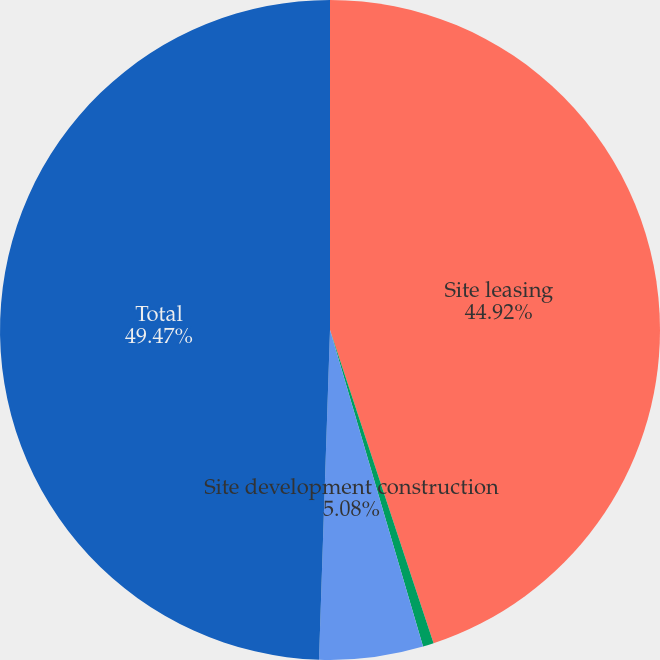Convert chart to OTSL. <chart><loc_0><loc_0><loc_500><loc_500><pie_chart><fcel>Site leasing<fcel>Site development consulting<fcel>Site development construction<fcel>Total<nl><fcel>44.92%<fcel>0.53%<fcel>5.08%<fcel>49.47%<nl></chart> 